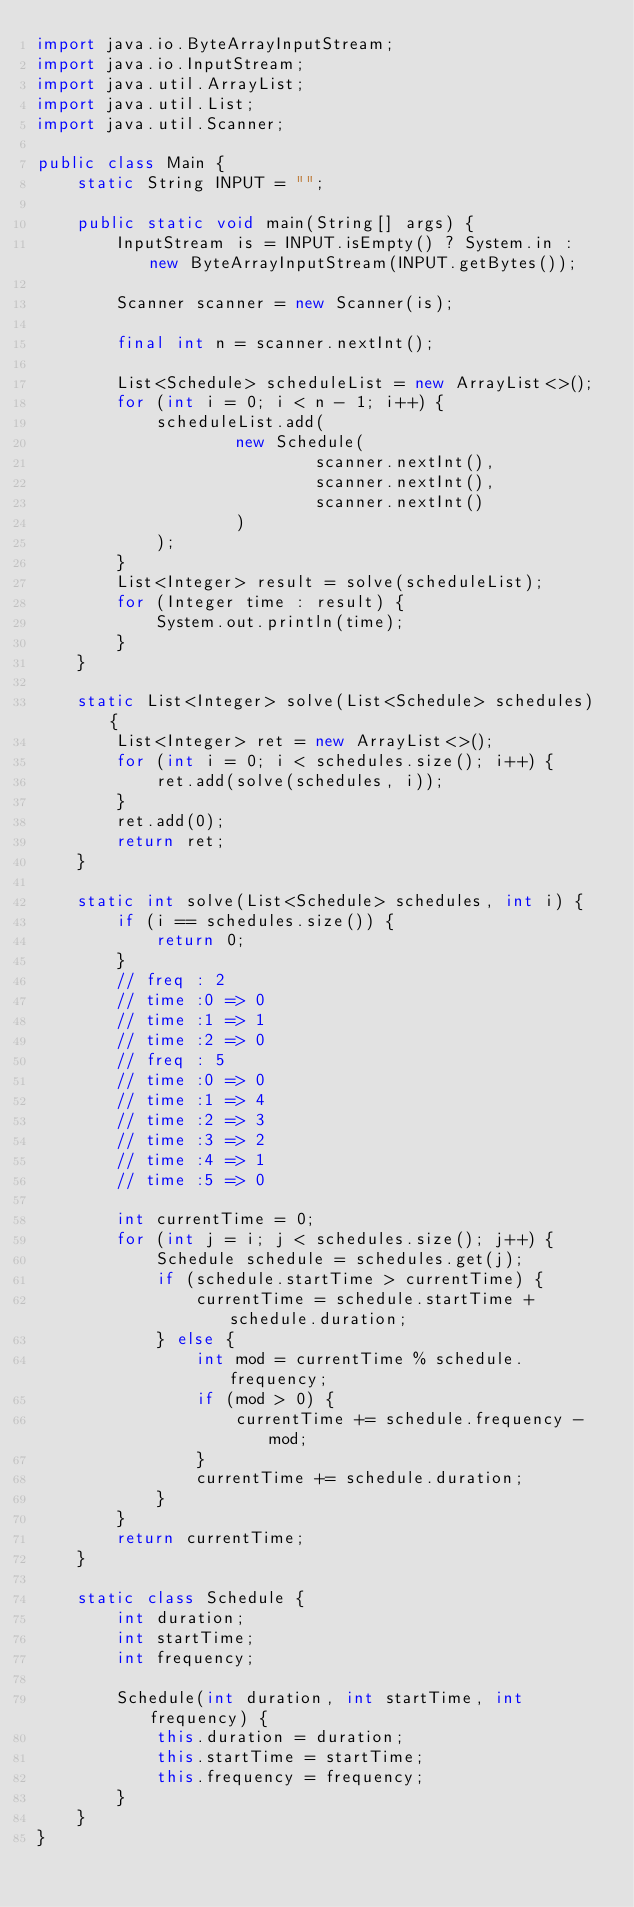Convert code to text. <code><loc_0><loc_0><loc_500><loc_500><_Java_>import java.io.ByteArrayInputStream;
import java.io.InputStream;
import java.util.ArrayList;
import java.util.List;
import java.util.Scanner;

public class Main {
    static String INPUT = "";

    public static void main(String[] args) {
        InputStream is = INPUT.isEmpty() ? System.in : new ByteArrayInputStream(INPUT.getBytes());

        Scanner scanner = new Scanner(is);

        final int n = scanner.nextInt();

        List<Schedule> scheduleList = new ArrayList<>();
        for (int i = 0; i < n - 1; i++) {
            scheduleList.add(
                    new Schedule(
                            scanner.nextInt(),
                            scanner.nextInt(),
                            scanner.nextInt()
                    )
            );
        }
        List<Integer> result = solve(scheduleList);
        for (Integer time : result) {
            System.out.println(time);
        }
    }

    static List<Integer> solve(List<Schedule> schedules) {
        List<Integer> ret = new ArrayList<>();
        for (int i = 0; i < schedules.size(); i++) {
            ret.add(solve(schedules, i));
        }
        ret.add(0);
        return ret;
    }

    static int solve(List<Schedule> schedules, int i) {
        if (i == schedules.size()) {
            return 0;
        }
        // freq : 2
        // time :0 => 0
        // time :1 => 1
        // time :2 => 0
        // freq : 5
        // time :0 => 0
        // time :1 => 4
        // time :2 => 3
        // time :3 => 2
        // time :4 => 1
        // time :5 => 0

        int currentTime = 0;
        for (int j = i; j < schedules.size(); j++) {
            Schedule schedule = schedules.get(j);
            if (schedule.startTime > currentTime) {
                currentTime = schedule.startTime + schedule.duration;
            } else {
                int mod = currentTime % schedule.frequency;
                if (mod > 0) {
                    currentTime += schedule.frequency - mod;
                }
                currentTime += schedule.duration;
            }
        }
        return currentTime;
    }

    static class Schedule {
        int duration;
        int startTime;
        int frequency;

        Schedule(int duration, int startTime, int frequency) {
            this.duration = duration;
            this.startTime = startTime;
            this.frequency = frequency;
        }
    }
}
</code> 